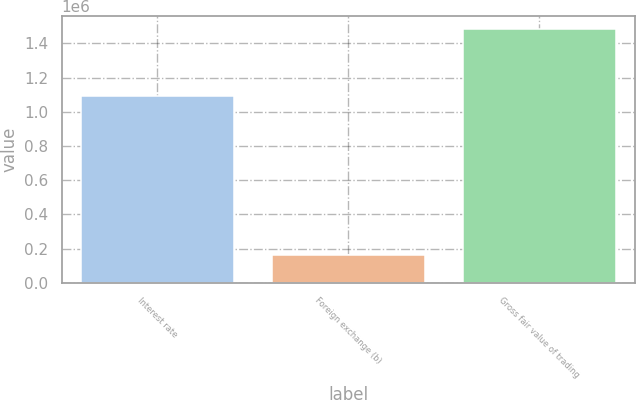<chart> <loc_0><loc_0><loc_500><loc_500><bar_chart><fcel>Interest rate<fcel>Foreign exchange (b)<fcel>Gross fair value of trading<nl><fcel>1.09044e+06<fcel>164730<fcel>1.48511e+06<nl></chart> 